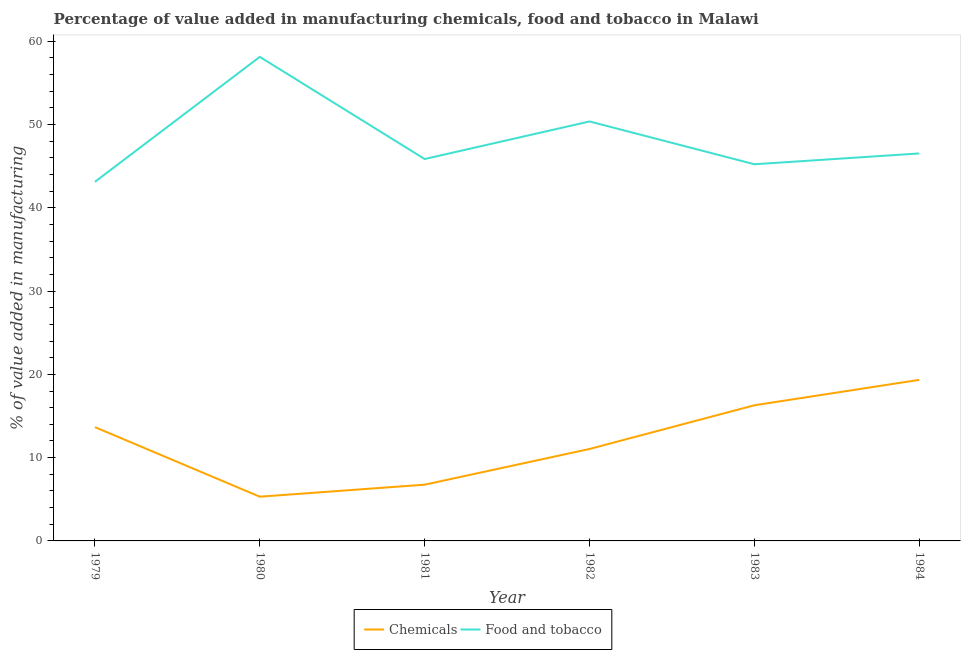How many different coloured lines are there?
Provide a succinct answer. 2. Does the line corresponding to value added by  manufacturing chemicals intersect with the line corresponding to value added by manufacturing food and tobacco?
Keep it short and to the point. No. Is the number of lines equal to the number of legend labels?
Offer a terse response. Yes. What is the value added by manufacturing food and tobacco in 1983?
Your answer should be very brief. 45.23. Across all years, what is the maximum value added by  manufacturing chemicals?
Your response must be concise. 19.34. Across all years, what is the minimum value added by manufacturing food and tobacco?
Ensure brevity in your answer.  43.12. In which year was the value added by manufacturing food and tobacco minimum?
Offer a very short reply. 1979. What is the total value added by manufacturing food and tobacco in the graph?
Give a very brief answer. 289.19. What is the difference between the value added by  manufacturing chemicals in 1981 and that in 1984?
Ensure brevity in your answer.  -12.58. What is the difference between the value added by  manufacturing chemicals in 1983 and the value added by manufacturing food and tobacco in 1979?
Your response must be concise. -26.83. What is the average value added by  manufacturing chemicals per year?
Give a very brief answer. 12.07. In the year 1979, what is the difference between the value added by  manufacturing chemicals and value added by manufacturing food and tobacco?
Offer a very short reply. -29.45. What is the ratio of the value added by manufacturing food and tobacco in 1983 to that in 1984?
Offer a very short reply. 0.97. What is the difference between the highest and the second highest value added by manufacturing food and tobacco?
Make the answer very short. 7.76. What is the difference between the highest and the lowest value added by manufacturing food and tobacco?
Keep it short and to the point. 15. In how many years, is the value added by  manufacturing chemicals greater than the average value added by  manufacturing chemicals taken over all years?
Make the answer very short. 3. Does the value added by manufacturing food and tobacco monotonically increase over the years?
Your answer should be very brief. No. How many lines are there?
Give a very brief answer. 2. What is the difference between two consecutive major ticks on the Y-axis?
Offer a very short reply. 10. Does the graph contain grids?
Offer a terse response. No. Where does the legend appear in the graph?
Your response must be concise. Bottom center. How many legend labels are there?
Offer a very short reply. 2. How are the legend labels stacked?
Make the answer very short. Horizontal. What is the title of the graph?
Give a very brief answer. Percentage of value added in manufacturing chemicals, food and tobacco in Malawi. What is the label or title of the Y-axis?
Make the answer very short. % of value added in manufacturing. What is the % of value added in manufacturing in Chemicals in 1979?
Provide a short and direct response. 13.66. What is the % of value added in manufacturing in Food and tobacco in 1979?
Your answer should be compact. 43.12. What is the % of value added in manufacturing of Chemicals in 1980?
Your answer should be very brief. 5.31. What is the % of value added in manufacturing of Food and tobacco in 1980?
Provide a short and direct response. 58.12. What is the % of value added in manufacturing in Chemicals in 1981?
Provide a succinct answer. 6.75. What is the % of value added in manufacturing in Food and tobacco in 1981?
Your answer should be compact. 45.85. What is the % of value added in manufacturing of Chemicals in 1982?
Offer a terse response. 11.04. What is the % of value added in manufacturing of Food and tobacco in 1982?
Your answer should be compact. 50.36. What is the % of value added in manufacturing in Chemicals in 1983?
Provide a succinct answer. 16.29. What is the % of value added in manufacturing in Food and tobacco in 1983?
Your answer should be compact. 45.23. What is the % of value added in manufacturing of Chemicals in 1984?
Your response must be concise. 19.34. What is the % of value added in manufacturing in Food and tobacco in 1984?
Offer a terse response. 46.52. Across all years, what is the maximum % of value added in manufacturing of Chemicals?
Your response must be concise. 19.34. Across all years, what is the maximum % of value added in manufacturing in Food and tobacco?
Your answer should be very brief. 58.12. Across all years, what is the minimum % of value added in manufacturing in Chemicals?
Your response must be concise. 5.31. Across all years, what is the minimum % of value added in manufacturing in Food and tobacco?
Your answer should be very brief. 43.12. What is the total % of value added in manufacturing in Chemicals in the graph?
Offer a very short reply. 72.39. What is the total % of value added in manufacturing in Food and tobacco in the graph?
Keep it short and to the point. 289.19. What is the difference between the % of value added in manufacturing in Chemicals in 1979 and that in 1980?
Keep it short and to the point. 8.35. What is the difference between the % of value added in manufacturing in Food and tobacco in 1979 and that in 1980?
Your answer should be compact. -15. What is the difference between the % of value added in manufacturing of Chemicals in 1979 and that in 1981?
Provide a short and direct response. 6.91. What is the difference between the % of value added in manufacturing of Food and tobacco in 1979 and that in 1981?
Ensure brevity in your answer.  -2.74. What is the difference between the % of value added in manufacturing of Chemicals in 1979 and that in 1982?
Your answer should be very brief. 2.62. What is the difference between the % of value added in manufacturing in Food and tobacco in 1979 and that in 1982?
Give a very brief answer. -7.25. What is the difference between the % of value added in manufacturing of Chemicals in 1979 and that in 1983?
Ensure brevity in your answer.  -2.63. What is the difference between the % of value added in manufacturing in Food and tobacco in 1979 and that in 1983?
Your answer should be compact. -2.11. What is the difference between the % of value added in manufacturing in Chemicals in 1979 and that in 1984?
Offer a very short reply. -5.68. What is the difference between the % of value added in manufacturing in Food and tobacco in 1979 and that in 1984?
Give a very brief answer. -3.41. What is the difference between the % of value added in manufacturing in Chemicals in 1980 and that in 1981?
Give a very brief answer. -1.44. What is the difference between the % of value added in manufacturing in Food and tobacco in 1980 and that in 1981?
Your answer should be compact. 12.27. What is the difference between the % of value added in manufacturing of Chemicals in 1980 and that in 1982?
Your answer should be very brief. -5.73. What is the difference between the % of value added in manufacturing in Food and tobacco in 1980 and that in 1982?
Your answer should be very brief. 7.76. What is the difference between the % of value added in manufacturing in Chemicals in 1980 and that in 1983?
Give a very brief answer. -10.98. What is the difference between the % of value added in manufacturing in Food and tobacco in 1980 and that in 1983?
Keep it short and to the point. 12.89. What is the difference between the % of value added in manufacturing in Chemicals in 1980 and that in 1984?
Your answer should be compact. -14.03. What is the difference between the % of value added in manufacturing of Food and tobacco in 1980 and that in 1984?
Your answer should be compact. 11.6. What is the difference between the % of value added in manufacturing in Chemicals in 1981 and that in 1982?
Your response must be concise. -4.29. What is the difference between the % of value added in manufacturing of Food and tobacco in 1981 and that in 1982?
Offer a terse response. -4.51. What is the difference between the % of value added in manufacturing of Chemicals in 1981 and that in 1983?
Make the answer very short. -9.53. What is the difference between the % of value added in manufacturing in Food and tobacco in 1981 and that in 1983?
Keep it short and to the point. 0.63. What is the difference between the % of value added in manufacturing in Chemicals in 1981 and that in 1984?
Offer a terse response. -12.58. What is the difference between the % of value added in manufacturing of Food and tobacco in 1981 and that in 1984?
Make the answer very short. -0.67. What is the difference between the % of value added in manufacturing of Chemicals in 1982 and that in 1983?
Ensure brevity in your answer.  -5.25. What is the difference between the % of value added in manufacturing of Food and tobacco in 1982 and that in 1983?
Keep it short and to the point. 5.14. What is the difference between the % of value added in manufacturing in Chemicals in 1982 and that in 1984?
Your answer should be compact. -8.3. What is the difference between the % of value added in manufacturing of Food and tobacco in 1982 and that in 1984?
Ensure brevity in your answer.  3.84. What is the difference between the % of value added in manufacturing of Chemicals in 1983 and that in 1984?
Provide a short and direct response. -3.05. What is the difference between the % of value added in manufacturing in Food and tobacco in 1983 and that in 1984?
Ensure brevity in your answer.  -1.3. What is the difference between the % of value added in manufacturing in Chemicals in 1979 and the % of value added in manufacturing in Food and tobacco in 1980?
Provide a short and direct response. -44.46. What is the difference between the % of value added in manufacturing of Chemicals in 1979 and the % of value added in manufacturing of Food and tobacco in 1981?
Offer a terse response. -32.19. What is the difference between the % of value added in manufacturing in Chemicals in 1979 and the % of value added in manufacturing in Food and tobacco in 1982?
Make the answer very short. -36.7. What is the difference between the % of value added in manufacturing in Chemicals in 1979 and the % of value added in manufacturing in Food and tobacco in 1983?
Give a very brief answer. -31.56. What is the difference between the % of value added in manufacturing in Chemicals in 1979 and the % of value added in manufacturing in Food and tobacco in 1984?
Your response must be concise. -32.86. What is the difference between the % of value added in manufacturing of Chemicals in 1980 and the % of value added in manufacturing of Food and tobacco in 1981?
Ensure brevity in your answer.  -40.54. What is the difference between the % of value added in manufacturing in Chemicals in 1980 and the % of value added in manufacturing in Food and tobacco in 1982?
Your answer should be very brief. -45.05. What is the difference between the % of value added in manufacturing in Chemicals in 1980 and the % of value added in manufacturing in Food and tobacco in 1983?
Offer a terse response. -39.91. What is the difference between the % of value added in manufacturing in Chemicals in 1980 and the % of value added in manufacturing in Food and tobacco in 1984?
Your answer should be compact. -41.21. What is the difference between the % of value added in manufacturing of Chemicals in 1981 and the % of value added in manufacturing of Food and tobacco in 1982?
Your answer should be compact. -43.61. What is the difference between the % of value added in manufacturing of Chemicals in 1981 and the % of value added in manufacturing of Food and tobacco in 1983?
Give a very brief answer. -38.47. What is the difference between the % of value added in manufacturing in Chemicals in 1981 and the % of value added in manufacturing in Food and tobacco in 1984?
Offer a terse response. -39.77. What is the difference between the % of value added in manufacturing of Chemicals in 1982 and the % of value added in manufacturing of Food and tobacco in 1983?
Provide a succinct answer. -34.19. What is the difference between the % of value added in manufacturing of Chemicals in 1982 and the % of value added in manufacturing of Food and tobacco in 1984?
Provide a short and direct response. -35.48. What is the difference between the % of value added in manufacturing of Chemicals in 1983 and the % of value added in manufacturing of Food and tobacco in 1984?
Your response must be concise. -30.23. What is the average % of value added in manufacturing of Chemicals per year?
Your response must be concise. 12.07. What is the average % of value added in manufacturing in Food and tobacco per year?
Provide a succinct answer. 48.2. In the year 1979, what is the difference between the % of value added in manufacturing of Chemicals and % of value added in manufacturing of Food and tobacco?
Provide a short and direct response. -29.45. In the year 1980, what is the difference between the % of value added in manufacturing in Chemicals and % of value added in manufacturing in Food and tobacco?
Offer a terse response. -52.81. In the year 1981, what is the difference between the % of value added in manufacturing of Chemicals and % of value added in manufacturing of Food and tobacco?
Your answer should be compact. -39.1. In the year 1982, what is the difference between the % of value added in manufacturing of Chemicals and % of value added in manufacturing of Food and tobacco?
Ensure brevity in your answer.  -39.32. In the year 1983, what is the difference between the % of value added in manufacturing of Chemicals and % of value added in manufacturing of Food and tobacco?
Provide a succinct answer. -28.94. In the year 1984, what is the difference between the % of value added in manufacturing of Chemicals and % of value added in manufacturing of Food and tobacco?
Provide a succinct answer. -27.18. What is the ratio of the % of value added in manufacturing in Chemicals in 1979 to that in 1980?
Your answer should be very brief. 2.57. What is the ratio of the % of value added in manufacturing in Food and tobacco in 1979 to that in 1980?
Give a very brief answer. 0.74. What is the ratio of the % of value added in manufacturing in Chemicals in 1979 to that in 1981?
Ensure brevity in your answer.  2.02. What is the ratio of the % of value added in manufacturing of Food and tobacco in 1979 to that in 1981?
Your answer should be compact. 0.94. What is the ratio of the % of value added in manufacturing of Chemicals in 1979 to that in 1982?
Give a very brief answer. 1.24. What is the ratio of the % of value added in manufacturing in Food and tobacco in 1979 to that in 1982?
Provide a short and direct response. 0.86. What is the ratio of the % of value added in manufacturing of Chemicals in 1979 to that in 1983?
Offer a very short reply. 0.84. What is the ratio of the % of value added in manufacturing of Food and tobacco in 1979 to that in 1983?
Provide a short and direct response. 0.95. What is the ratio of the % of value added in manufacturing of Chemicals in 1979 to that in 1984?
Provide a succinct answer. 0.71. What is the ratio of the % of value added in manufacturing of Food and tobacco in 1979 to that in 1984?
Provide a succinct answer. 0.93. What is the ratio of the % of value added in manufacturing of Chemicals in 1980 to that in 1981?
Ensure brevity in your answer.  0.79. What is the ratio of the % of value added in manufacturing of Food and tobacco in 1980 to that in 1981?
Provide a short and direct response. 1.27. What is the ratio of the % of value added in manufacturing of Chemicals in 1980 to that in 1982?
Keep it short and to the point. 0.48. What is the ratio of the % of value added in manufacturing of Food and tobacco in 1980 to that in 1982?
Provide a short and direct response. 1.15. What is the ratio of the % of value added in manufacturing in Chemicals in 1980 to that in 1983?
Ensure brevity in your answer.  0.33. What is the ratio of the % of value added in manufacturing of Food and tobacco in 1980 to that in 1983?
Provide a succinct answer. 1.29. What is the ratio of the % of value added in manufacturing in Chemicals in 1980 to that in 1984?
Offer a terse response. 0.27. What is the ratio of the % of value added in manufacturing of Food and tobacco in 1980 to that in 1984?
Give a very brief answer. 1.25. What is the ratio of the % of value added in manufacturing of Chemicals in 1981 to that in 1982?
Your answer should be very brief. 0.61. What is the ratio of the % of value added in manufacturing in Food and tobacco in 1981 to that in 1982?
Your answer should be very brief. 0.91. What is the ratio of the % of value added in manufacturing of Chemicals in 1981 to that in 1983?
Offer a very short reply. 0.41. What is the ratio of the % of value added in manufacturing in Food and tobacco in 1981 to that in 1983?
Your answer should be compact. 1.01. What is the ratio of the % of value added in manufacturing of Chemicals in 1981 to that in 1984?
Offer a very short reply. 0.35. What is the ratio of the % of value added in manufacturing of Food and tobacco in 1981 to that in 1984?
Keep it short and to the point. 0.99. What is the ratio of the % of value added in manufacturing in Chemicals in 1982 to that in 1983?
Keep it short and to the point. 0.68. What is the ratio of the % of value added in manufacturing in Food and tobacco in 1982 to that in 1983?
Provide a short and direct response. 1.11. What is the ratio of the % of value added in manufacturing of Chemicals in 1982 to that in 1984?
Keep it short and to the point. 0.57. What is the ratio of the % of value added in manufacturing in Food and tobacco in 1982 to that in 1984?
Your answer should be very brief. 1.08. What is the ratio of the % of value added in manufacturing of Chemicals in 1983 to that in 1984?
Keep it short and to the point. 0.84. What is the ratio of the % of value added in manufacturing of Food and tobacco in 1983 to that in 1984?
Your answer should be compact. 0.97. What is the difference between the highest and the second highest % of value added in manufacturing in Chemicals?
Your response must be concise. 3.05. What is the difference between the highest and the second highest % of value added in manufacturing in Food and tobacco?
Your answer should be compact. 7.76. What is the difference between the highest and the lowest % of value added in manufacturing in Chemicals?
Keep it short and to the point. 14.03. What is the difference between the highest and the lowest % of value added in manufacturing of Food and tobacco?
Ensure brevity in your answer.  15. 